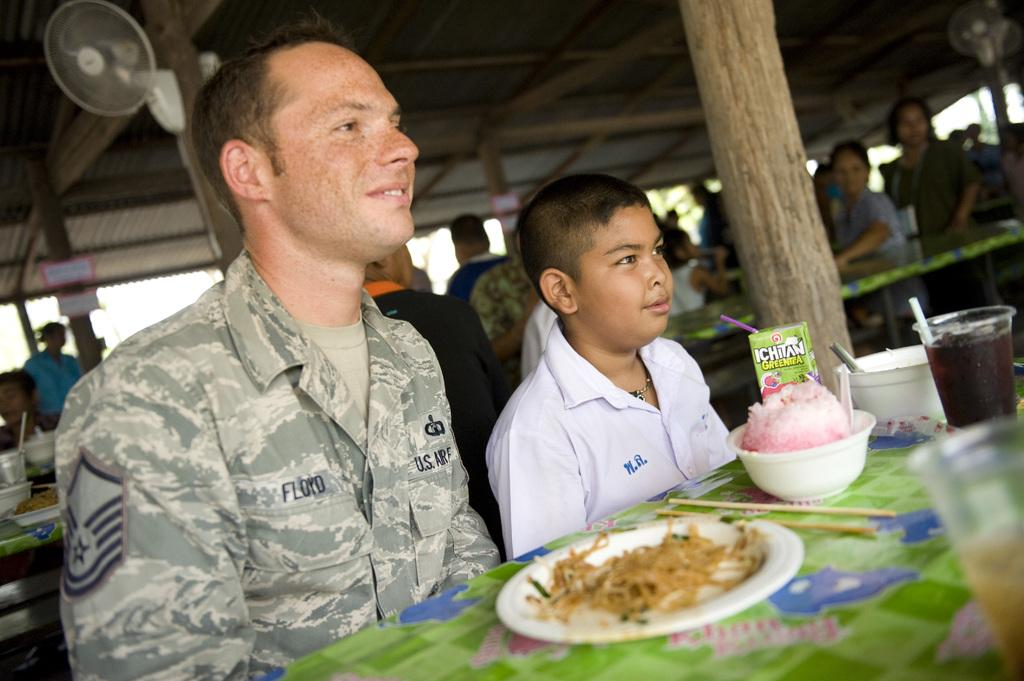What can be seen in the image? There are people, tables, chairs, plates, bowls, glasses, fans, and a shed at the top of the image. What might the people be using the tables and chairs for? The people might be using the tables and chairs for dining or gathering. What objects are present for serving or eating food? Plates, bowls, and glasses are present for serving or eating food. What is providing air circulation in the image? Fans are providing air circulation in the image. What part of the natural environment is visible in the image? The sky is visible in the image. What type of class is being taught in the image? There is no class or teaching activity depicted in the image. What cast members are present in the image? There are no cast members or actors present in the image. 